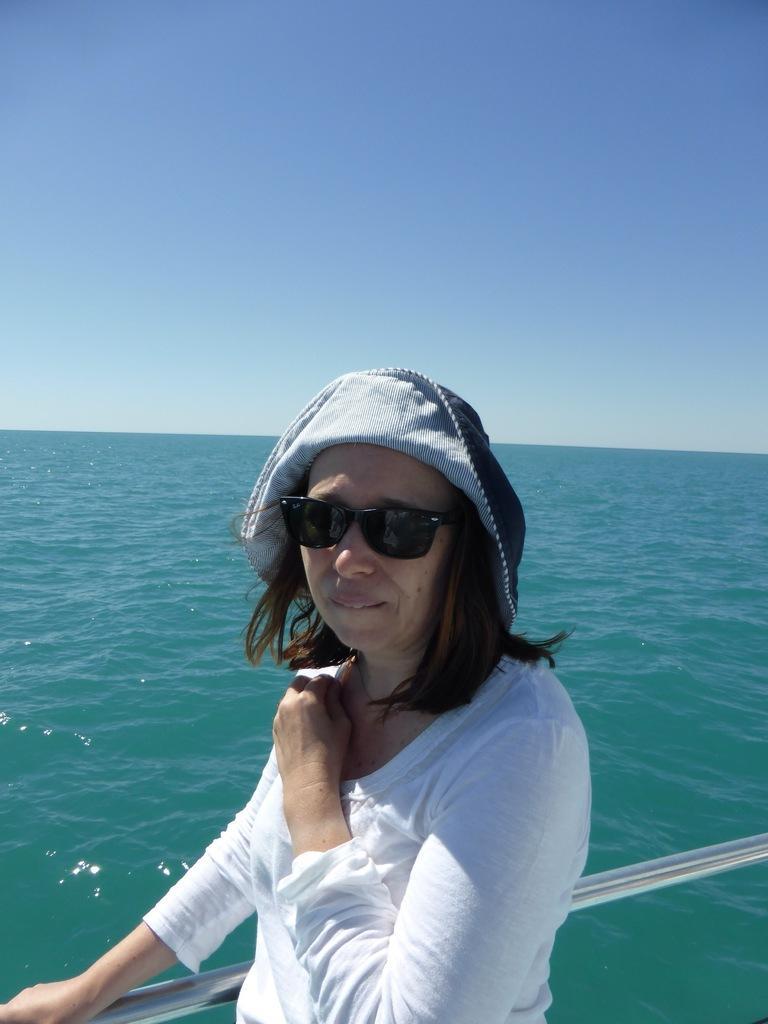Describe this image in one or two sentences. Here I can see a woman wearing white color t-shirt, cap on the head, goggles, holding the railing, standing and looking at the picture. In the background there is an Ocean. At the top of the image I can see the sky in blue color. 